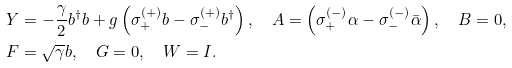<formula> <loc_0><loc_0><loc_500><loc_500>& Y = - \frac { \gamma } { 2 } b ^ { \dag } b + g \left ( \sigma _ { + } ^ { ( + ) } b - \sigma _ { - } ^ { ( + ) } b ^ { \dag } \right ) , \quad A = \left ( \sigma _ { + } ^ { ( - ) } \alpha - \sigma _ { - } ^ { ( - ) } \bar { \alpha } \right ) , \quad B = 0 , \\ & F = \sqrt { \gamma } b , \quad G = 0 , \quad W = I .</formula> 